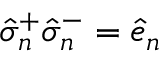Convert formula to latex. <formula><loc_0><loc_0><loc_500><loc_500>\hat { \sigma } _ { n } ^ { + } \hat { \sigma } _ { n } ^ { - } = \hat { e } _ { n }</formula> 